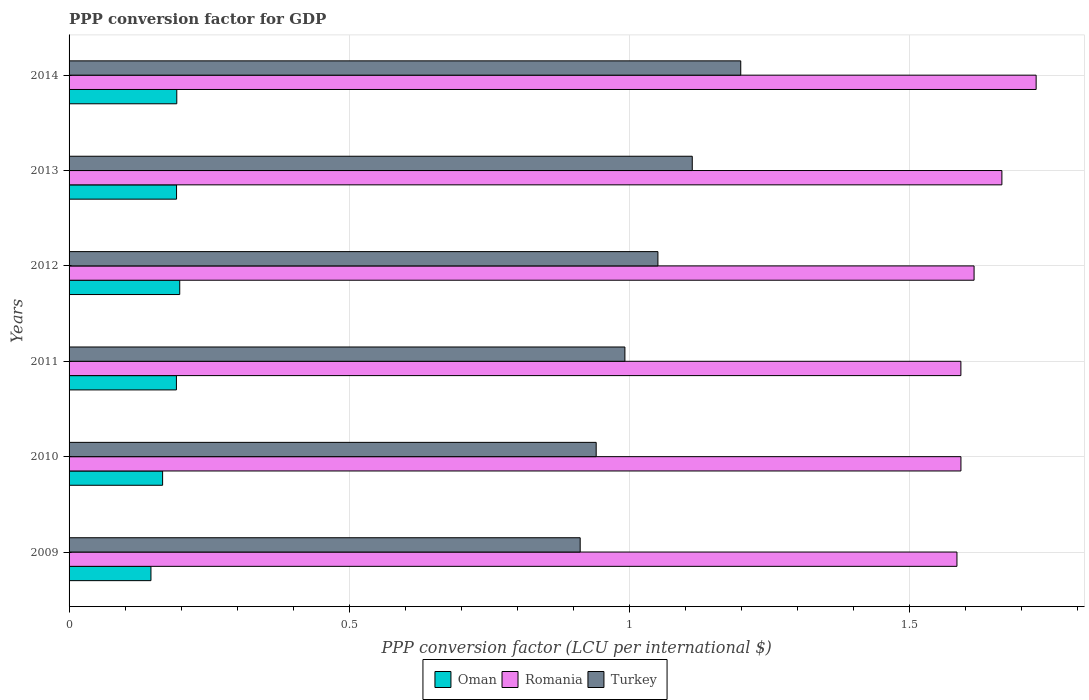How many groups of bars are there?
Offer a terse response. 6. Are the number of bars on each tick of the Y-axis equal?
Provide a short and direct response. Yes. How many bars are there on the 5th tick from the top?
Provide a short and direct response. 3. How many bars are there on the 2nd tick from the bottom?
Provide a short and direct response. 3. In how many cases, is the number of bars for a given year not equal to the number of legend labels?
Make the answer very short. 0. What is the PPP conversion factor for GDP in Oman in 2014?
Provide a succinct answer. 0.19. Across all years, what is the maximum PPP conversion factor for GDP in Oman?
Give a very brief answer. 0.2. Across all years, what is the minimum PPP conversion factor for GDP in Turkey?
Give a very brief answer. 0.91. In which year was the PPP conversion factor for GDP in Turkey maximum?
Give a very brief answer. 2014. What is the total PPP conversion factor for GDP in Romania in the graph?
Your answer should be very brief. 9.77. What is the difference between the PPP conversion factor for GDP in Romania in 2009 and that in 2010?
Your response must be concise. -0.01. What is the difference between the PPP conversion factor for GDP in Oman in 2011 and the PPP conversion factor for GDP in Turkey in 2013?
Your response must be concise. -0.92. What is the average PPP conversion factor for GDP in Romania per year?
Your answer should be compact. 1.63. In the year 2012, what is the difference between the PPP conversion factor for GDP in Oman and PPP conversion factor for GDP in Romania?
Your answer should be compact. -1.42. What is the ratio of the PPP conversion factor for GDP in Romania in 2010 to that in 2012?
Provide a succinct answer. 0.99. Is the difference between the PPP conversion factor for GDP in Oman in 2013 and 2014 greater than the difference between the PPP conversion factor for GDP in Romania in 2013 and 2014?
Your answer should be compact. Yes. What is the difference between the highest and the second highest PPP conversion factor for GDP in Turkey?
Your answer should be compact. 0.09. What is the difference between the highest and the lowest PPP conversion factor for GDP in Turkey?
Provide a succinct answer. 0.29. In how many years, is the PPP conversion factor for GDP in Oman greater than the average PPP conversion factor for GDP in Oman taken over all years?
Offer a very short reply. 4. Is the sum of the PPP conversion factor for GDP in Turkey in 2010 and 2012 greater than the maximum PPP conversion factor for GDP in Romania across all years?
Your answer should be very brief. Yes. What does the 2nd bar from the top in 2012 represents?
Provide a succinct answer. Romania. How many years are there in the graph?
Your answer should be very brief. 6. What is the difference between two consecutive major ticks on the X-axis?
Your answer should be compact. 0.5. Does the graph contain any zero values?
Your response must be concise. No. How many legend labels are there?
Your answer should be very brief. 3. How are the legend labels stacked?
Your answer should be compact. Horizontal. What is the title of the graph?
Keep it short and to the point. PPP conversion factor for GDP. Does "Kosovo" appear as one of the legend labels in the graph?
Keep it short and to the point. No. What is the label or title of the X-axis?
Provide a short and direct response. PPP conversion factor (LCU per international $). What is the PPP conversion factor (LCU per international $) of Oman in 2009?
Provide a short and direct response. 0.15. What is the PPP conversion factor (LCU per international $) of Romania in 2009?
Your answer should be compact. 1.58. What is the PPP conversion factor (LCU per international $) in Turkey in 2009?
Make the answer very short. 0.91. What is the PPP conversion factor (LCU per international $) in Oman in 2010?
Provide a short and direct response. 0.17. What is the PPP conversion factor (LCU per international $) in Romania in 2010?
Provide a succinct answer. 1.59. What is the PPP conversion factor (LCU per international $) of Turkey in 2010?
Keep it short and to the point. 0.94. What is the PPP conversion factor (LCU per international $) in Oman in 2011?
Your answer should be very brief. 0.19. What is the PPP conversion factor (LCU per international $) of Romania in 2011?
Give a very brief answer. 1.59. What is the PPP conversion factor (LCU per international $) in Turkey in 2011?
Provide a short and direct response. 0.99. What is the PPP conversion factor (LCU per international $) of Oman in 2012?
Provide a succinct answer. 0.2. What is the PPP conversion factor (LCU per international $) in Romania in 2012?
Provide a short and direct response. 1.61. What is the PPP conversion factor (LCU per international $) in Turkey in 2012?
Offer a very short reply. 1.05. What is the PPP conversion factor (LCU per international $) in Oman in 2013?
Provide a short and direct response. 0.19. What is the PPP conversion factor (LCU per international $) of Romania in 2013?
Offer a very short reply. 1.66. What is the PPP conversion factor (LCU per international $) in Turkey in 2013?
Your answer should be very brief. 1.11. What is the PPP conversion factor (LCU per international $) in Oman in 2014?
Offer a terse response. 0.19. What is the PPP conversion factor (LCU per international $) of Romania in 2014?
Your answer should be compact. 1.73. What is the PPP conversion factor (LCU per international $) in Turkey in 2014?
Make the answer very short. 1.2. Across all years, what is the maximum PPP conversion factor (LCU per international $) of Oman?
Make the answer very short. 0.2. Across all years, what is the maximum PPP conversion factor (LCU per international $) of Romania?
Your answer should be compact. 1.73. Across all years, what is the maximum PPP conversion factor (LCU per international $) in Turkey?
Provide a succinct answer. 1.2. Across all years, what is the minimum PPP conversion factor (LCU per international $) in Oman?
Ensure brevity in your answer.  0.15. Across all years, what is the minimum PPP conversion factor (LCU per international $) in Romania?
Your response must be concise. 1.58. Across all years, what is the minimum PPP conversion factor (LCU per international $) of Turkey?
Offer a very short reply. 0.91. What is the total PPP conversion factor (LCU per international $) in Oman in the graph?
Ensure brevity in your answer.  1.09. What is the total PPP conversion factor (LCU per international $) in Romania in the graph?
Your answer should be very brief. 9.77. What is the total PPP conversion factor (LCU per international $) of Turkey in the graph?
Keep it short and to the point. 6.21. What is the difference between the PPP conversion factor (LCU per international $) of Oman in 2009 and that in 2010?
Give a very brief answer. -0.02. What is the difference between the PPP conversion factor (LCU per international $) in Romania in 2009 and that in 2010?
Your answer should be very brief. -0.01. What is the difference between the PPP conversion factor (LCU per international $) of Turkey in 2009 and that in 2010?
Give a very brief answer. -0.03. What is the difference between the PPP conversion factor (LCU per international $) in Oman in 2009 and that in 2011?
Your response must be concise. -0.05. What is the difference between the PPP conversion factor (LCU per international $) in Romania in 2009 and that in 2011?
Give a very brief answer. -0.01. What is the difference between the PPP conversion factor (LCU per international $) in Turkey in 2009 and that in 2011?
Give a very brief answer. -0.08. What is the difference between the PPP conversion factor (LCU per international $) of Oman in 2009 and that in 2012?
Offer a terse response. -0.05. What is the difference between the PPP conversion factor (LCU per international $) of Romania in 2009 and that in 2012?
Provide a succinct answer. -0.03. What is the difference between the PPP conversion factor (LCU per international $) in Turkey in 2009 and that in 2012?
Keep it short and to the point. -0.14. What is the difference between the PPP conversion factor (LCU per international $) in Oman in 2009 and that in 2013?
Provide a short and direct response. -0.05. What is the difference between the PPP conversion factor (LCU per international $) in Romania in 2009 and that in 2013?
Offer a terse response. -0.08. What is the difference between the PPP conversion factor (LCU per international $) of Oman in 2009 and that in 2014?
Your response must be concise. -0.05. What is the difference between the PPP conversion factor (LCU per international $) of Romania in 2009 and that in 2014?
Your answer should be very brief. -0.14. What is the difference between the PPP conversion factor (LCU per international $) of Turkey in 2009 and that in 2014?
Offer a terse response. -0.29. What is the difference between the PPP conversion factor (LCU per international $) in Oman in 2010 and that in 2011?
Keep it short and to the point. -0.02. What is the difference between the PPP conversion factor (LCU per international $) of Romania in 2010 and that in 2011?
Your answer should be very brief. 0. What is the difference between the PPP conversion factor (LCU per international $) of Turkey in 2010 and that in 2011?
Provide a succinct answer. -0.05. What is the difference between the PPP conversion factor (LCU per international $) in Oman in 2010 and that in 2012?
Provide a short and direct response. -0.03. What is the difference between the PPP conversion factor (LCU per international $) of Romania in 2010 and that in 2012?
Provide a short and direct response. -0.02. What is the difference between the PPP conversion factor (LCU per international $) in Turkey in 2010 and that in 2012?
Your answer should be compact. -0.11. What is the difference between the PPP conversion factor (LCU per international $) of Oman in 2010 and that in 2013?
Keep it short and to the point. -0.02. What is the difference between the PPP conversion factor (LCU per international $) in Romania in 2010 and that in 2013?
Offer a terse response. -0.07. What is the difference between the PPP conversion factor (LCU per international $) of Turkey in 2010 and that in 2013?
Offer a very short reply. -0.17. What is the difference between the PPP conversion factor (LCU per international $) of Oman in 2010 and that in 2014?
Keep it short and to the point. -0.03. What is the difference between the PPP conversion factor (LCU per international $) of Romania in 2010 and that in 2014?
Your response must be concise. -0.13. What is the difference between the PPP conversion factor (LCU per international $) of Turkey in 2010 and that in 2014?
Give a very brief answer. -0.26. What is the difference between the PPP conversion factor (LCU per international $) of Oman in 2011 and that in 2012?
Ensure brevity in your answer.  -0.01. What is the difference between the PPP conversion factor (LCU per international $) in Romania in 2011 and that in 2012?
Your answer should be very brief. -0.02. What is the difference between the PPP conversion factor (LCU per international $) of Turkey in 2011 and that in 2012?
Provide a short and direct response. -0.06. What is the difference between the PPP conversion factor (LCU per international $) in Oman in 2011 and that in 2013?
Your answer should be very brief. -0. What is the difference between the PPP conversion factor (LCU per international $) in Romania in 2011 and that in 2013?
Your answer should be very brief. -0.07. What is the difference between the PPP conversion factor (LCU per international $) in Turkey in 2011 and that in 2013?
Offer a terse response. -0.12. What is the difference between the PPP conversion factor (LCU per international $) in Oman in 2011 and that in 2014?
Your answer should be compact. -0. What is the difference between the PPP conversion factor (LCU per international $) in Romania in 2011 and that in 2014?
Your answer should be very brief. -0.13. What is the difference between the PPP conversion factor (LCU per international $) in Turkey in 2011 and that in 2014?
Give a very brief answer. -0.21. What is the difference between the PPP conversion factor (LCU per international $) of Oman in 2012 and that in 2013?
Provide a short and direct response. 0.01. What is the difference between the PPP conversion factor (LCU per international $) in Romania in 2012 and that in 2013?
Your response must be concise. -0.05. What is the difference between the PPP conversion factor (LCU per international $) in Turkey in 2012 and that in 2013?
Keep it short and to the point. -0.06. What is the difference between the PPP conversion factor (LCU per international $) of Oman in 2012 and that in 2014?
Your answer should be very brief. 0.01. What is the difference between the PPP conversion factor (LCU per international $) in Romania in 2012 and that in 2014?
Provide a short and direct response. -0.11. What is the difference between the PPP conversion factor (LCU per international $) in Turkey in 2012 and that in 2014?
Offer a very short reply. -0.15. What is the difference between the PPP conversion factor (LCU per international $) of Oman in 2013 and that in 2014?
Give a very brief answer. -0. What is the difference between the PPP conversion factor (LCU per international $) of Romania in 2013 and that in 2014?
Offer a very short reply. -0.06. What is the difference between the PPP conversion factor (LCU per international $) in Turkey in 2013 and that in 2014?
Offer a very short reply. -0.09. What is the difference between the PPP conversion factor (LCU per international $) of Oman in 2009 and the PPP conversion factor (LCU per international $) of Romania in 2010?
Your answer should be very brief. -1.45. What is the difference between the PPP conversion factor (LCU per international $) in Oman in 2009 and the PPP conversion factor (LCU per international $) in Turkey in 2010?
Make the answer very short. -0.79. What is the difference between the PPP conversion factor (LCU per international $) of Romania in 2009 and the PPP conversion factor (LCU per international $) of Turkey in 2010?
Ensure brevity in your answer.  0.64. What is the difference between the PPP conversion factor (LCU per international $) in Oman in 2009 and the PPP conversion factor (LCU per international $) in Romania in 2011?
Make the answer very short. -1.45. What is the difference between the PPP conversion factor (LCU per international $) of Oman in 2009 and the PPP conversion factor (LCU per international $) of Turkey in 2011?
Ensure brevity in your answer.  -0.85. What is the difference between the PPP conversion factor (LCU per international $) of Romania in 2009 and the PPP conversion factor (LCU per international $) of Turkey in 2011?
Provide a succinct answer. 0.59. What is the difference between the PPP conversion factor (LCU per international $) of Oman in 2009 and the PPP conversion factor (LCU per international $) of Romania in 2012?
Make the answer very short. -1.47. What is the difference between the PPP conversion factor (LCU per international $) in Oman in 2009 and the PPP conversion factor (LCU per international $) in Turkey in 2012?
Your answer should be very brief. -0.9. What is the difference between the PPP conversion factor (LCU per international $) of Romania in 2009 and the PPP conversion factor (LCU per international $) of Turkey in 2012?
Your answer should be compact. 0.53. What is the difference between the PPP conversion factor (LCU per international $) of Oman in 2009 and the PPP conversion factor (LCU per international $) of Romania in 2013?
Your answer should be compact. -1.52. What is the difference between the PPP conversion factor (LCU per international $) of Oman in 2009 and the PPP conversion factor (LCU per international $) of Turkey in 2013?
Your response must be concise. -0.97. What is the difference between the PPP conversion factor (LCU per international $) of Romania in 2009 and the PPP conversion factor (LCU per international $) of Turkey in 2013?
Ensure brevity in your answer.  0.47. What is the difference between the PPP conversion factor (LCU per international $) of Oman in 2009 and the PPP conversion factor (LCU per international $) of Romania in 2014?
Offer a very short reply. -1.58. What is the difference between the PPP conversion factor (LCU per international $) of Oman in 2009 and the PPP conversion factor (LCU per international $) of Turkey in 2014?
Offer a very short reply. -1.05. What is the difference between the PPP conversion factor (LCU per international $) in Romania in 2009 and the PPP conversion factor (LCU per international $) in Turkey in 2014?
Offer a terse response. 0.39. What is the difference between the PPP conversion factor (LCU per international $) in Oman in 2010 and the PPP conversion factor (LCU per international $) in Romania in 2011?
Ensure brevity in your answer.  -1.42. What is the difference between the PPP conversion factor (LCU per international $) of Oman in 2010 and the PPP conversion factor (LCU per international $) of Turkey in 2011?
Your answer should be compact. -0.82. What is the difference between the PPP conversion factor (LCU per international $) of Romania in 2010 and the PPP conversion factor (LCU per international $) of Turkey in 2011?
Your response must be concise. 0.6. What is the difference between the PPP conversion factor (LCU per international $) of Oman in 2010 and the PPP conversion factor (LCU per international $) of Romania in 2012?
Provide a short and direct response. -1.45. What is the difference between the PPP conversion factor (LCU per international $) of Oman in 2010 and the PPP conversion factor (LCU per international $) of Turkey in 2012?
Provide a succinct answer. -0.88. What is the difference between the PPP conversion factor (LCU per international $) in Romania in 2010 and the PPP conversion factor (LCU per international $) in Turkey in 2012?
Offer a very short reply. 0.54. What is the difference between the PPP conversion factor (LCU per international $) in Oman in 2010 and the PPP conversion factor (LCU per international $) in Romania in 2013?
Your answer should be very brief. -1.5. What is the difference between the PPP conversion factor (LCU per international $) of Oman in 2010 and the PPP conversion factor (LCU per international $) of Turkey in 2013?
Your response must be concise. -0.95. What is the difference between the PPP conversion factor (LCU per international $) of Romania in 2010 and the PPP conversion factor (LCU per international $) of Turkey in 2013?
Provide a succinct answer. 0.48. What is the difference between the PPP conversion factor (LCU per international $) of Oman in 2010 and the PPP conversion factor (LCU per international $) of Romania in 2014?
Your answer should be very brief. -1.56. What is the difference between the PPP conversion factor (LCU per international $) in Oman in 2010 and the PPP conversion factor (LCU per international $) in Turkey in 2014?
Your answer should be very brief. -1.03. What is the difference between the PPP conversion factor (LCU per international $) of Romania in 2010 and the PPP conversion factor (LCU per international $) of Turkey in 2014?
Your answer should be compact. 0.39. What is the difference between the PPP conversion factor (LCU per international $) of Oman in 2011 and the PPP conversion factor (LCU per international $) of Romania in 2012?
Your answer should be very brief. -1.42. What is the difference between the PPP conversion factor (LCU per international $) in Oman in 2011 and the PPP conversion factor (LCU per international $) in Turkey in 2012?
Offer a very short reply. -0.86. What is the difference between the PPP conversion factor (LCU per international $) in Romania in 2011 and the PPP conversion factor (LCU per international $) in Turkey in 2012?
Make the answer very short. 0.54. What is the difference between the PPP conversion factor (LCU per international $) in Oman in 2011 and the PPP conversion factor (LCU per international $) in Romania in 2013?
Ensure brevity in your answer.  -1.47. What is the difference between the PPP conversion factor (LCU per international $) in Oman in 2011 and the PPP conversion factor (LCU per international $) in Turkey in 2013?
Make the answer very short. -0.92. What is the difference between the PPP conversion factor (LCU per international $) of Romania in 2011 and the PPP conversion factor (LCU per international $) of Turkey in 2013?
Your answer should be very brief. 0.48. What is the difference between the PPP conversion factor (LCU per international $) in Oman in 2011 and the PPP conversion factor (LCU per international $) in Romania in 2014?
Make the answer very short. -1.53. What is the difference between the PPP conversion factor (LCU per international $) in Oman in 2011 and the PPP conversion factor (LCU per international $) in Turkey in 2014?
Your answer should be compact. -1.01. What is the difference between the PPP conversion factor (LCU per international $) in Romania in 2011 and the PPP conversion factor (LCU per international $) in Turkey in 2014?
Provide a short and direct response. 0.39. What is the difference between the PPP conversion factor (LCU per international $) in Oman in 2012 and the PPP conversion factor (LCU per international $) in Romania in 2013?
Offer a very short reply. -1.47. What is the difference between the PPP conversion factor (LCU per international $) in Oman in 2012 and the PPP conversion factor (LCU per international $) in Turkey in 2013?
Keep it short and to the point. -0.91. What is the difference between the PPP conversion factor (LCU per international $) of Romania in 2012 and the PPP conversion factor (LCU per international $) of Turkey in 2013?
Provide a short and direct response. 0.5. What is the difference between the PPP conversion factor (LCU per international $) of Oman in 2012 and the PPP conversion factor (LCU per international $) of Romania in 2014?
Give a very brief answer. -1.53. What is the difference between the PPP conversion factor (LCU per international $) in Oman in 2012 and the PPP conversion factor (LCU per international $) in Turkey in 2014?
Ensure brevity in your answer.  -1. What is the difference between the PPP conversion factor (LCU per international $) of Romania in 2012 and the PPP conversion factor (LCU per international $) of Turkey in 2014?
Offer a terse response. 0.42. What is the difference between the PPP conversion factor (LCU per international $) of Oman in 2013 and the PPP conversion factor (LCU per international $) of Romania in 2014?
Offer a very short reply. -1.53. What is the difference between the PPP conversion factor (LCU per international $) in Oman in 2013 and the PPP conversion factor (LCU per international $) in Turkey in 2014?
Your response must be concise. -1.01. What is the difference between the PPP conversion factor (LCU per international $) of Romania in 2013 and the PPP conversion factor (LCU per international $) of Turkey in 2014?
Make the answer very short. 0.47. What is the average PPP conversion factor (LCU per international $) in Oman per year?
Your response must be concise. 0.18. What is the average PPP conversion factor (LCU per international $) of Romania per year?
Give a very brief answer. 1.63. What is the average PPP conversion factor (LCU per international $) in Turkey per year?
Provide a short and direct response. 1.03. In the year 2009, what is the difference between the PPP conversion factor (LCU per international $) in Oman and PPP conversion factor (LCU per international $) in Romania?
Your response must be concise. -1.44. In the year 2009, what is the difference between the PPP conversion factor (LCU per international $) of Oman and PPP conversion factor (LCU per international $) of Turkey?
Provide a succinct answer. -0.77. In the year 2009, what is the difference between the PPP conversion factor (LCU per international $) in Romania and PPP conversion factor (LCU per international $) in Turkey?
Your answer should be compact. 0.67. In the year 2010, what is the difference between the PPP conversion factor (LCU per international $) of Oman and PPP conversion factor (LCU per international $) of Romania?
Give a very brief answer. -1.42. In the year 2010, what is the difference between the PPP conversion factor (LCU per international $) in Oman and PPP conversion factor (LCU per international $) in Turkey?
Offer a terse response. -0.77. In the year 2010, what is the difference between the PPP conversion factor (LCU per international $) of Romania and PPP conversion factor (LCU per international $) of Turkey?
Your answer should be very brief. 0.65. In the year 2011, what is the difference between the PPP conversion factor (LCU per international $) of Oman and PPP conversion factor (LCU per international $) of Romania?
Give a very brief answer. -1.4. In the year 2011, what is the difference between the PPP conversion factor (LCU per international $) of Oman and PPP conversion factor (LCU per international $) of Turkey?
Ensure brevity in your answer.  -0.8. In the year 2011, what is the difference between the PPP conversion factor (LCU per international $) in Romania and PPP conversion factor (LCU per international $) in Turkey?
Ensure brevity in your answer.  0.6. In the year 2012, what is the difference between the PPP conversion factor (LCU per international $) in Oman and PPP conversion factor (LCU per international $) in Romania?
Offer a very short reply. -1.42. In the year 2012, what is the difference between the PPP conversion factor (LCU per international $) of Oman and PPP conversion factor (LCU per international $) of Turkey?
Offer a very short reply. -0.85. In the year 2012, what is the difference between the PPP conversion factor (LCU per international $) in Romania and PPP conversion factor (LCU per international $) in Turkey?
Your answer should be compact. 0.56. In the year 2013, what is the difference between the PPP conversion factor (LCU per international $) of Oman and PPP conversion factor (LCU per international $) of Romania?
Offer a very short reply. -1.47. In the year 2013, what is the difference between the PPP conversion factor (LCU per international $) of Oman and PPP conversion factor (LCU per international $) of Turkey?
Your response must be concise. -0.92. In the year 2013, what is the difference between the PPP conversion factor (LCU per international $) in Romania and PPP conversion factor (LCU per international $) in Turkey?
Ensure brevity in your answer.  0.55. In the year 2014, what is the difference between the PPP conversion factor (LCU per international $) of Oman and PPP conversion factor (LCU per international $) of Romania?
Give a very brief answer. -1.53. In the year 2014, what is the difference between the PPP conversion factor (LCU per international $) of Oman and PPP conversion factor (LCU per international $) of Turkey?
Offer a terse response. -1.01. In the year 2014, what is the difference between the PPP conversion factor (LCU per international $) in Romania and PPP conversion factor (LCU per international $) in Turkey?
Your answer should be compact. 0.53. What is the ratio of the PPP conversion factor (LCU per international $) in Oman in 2009 to that in 2010?
Your response must be concise. 0.88. What is the ratio of the PPP conversion factor (LCU per international $) of Romania in 2009 to that in 2010?
Provide a succinct answer. 1. What is the ratio of the PPP conversion factor (LCU per international $) in Turkey in 2009 to that in 2010?
Your answer should be very brief. 0.97. What is the ratio of the PPP conversion factor (LCU per international $) of Oman in 2009 to that in 2011?
Your answer should be compact. 0.76. What is the ratio of the PPP conversion factor (LCU per international $) in Romania in 2009 to that in 2011?
Your response must be concise. 1. What is the ratio of the PPP conversion factor (LCU per international $) of Turkey in 2009 to that in 2011?
Your answer should be very brief. 0.92. What is the ratio of the PPP conversion factor (LCU per international $) of Oman in 2009 to that in 2012?
Your response must be concise. 0.74. What is the ratio of the PPP conversion factor (LCU per international $) in Romania in 2009 to that in 2012?
Make the answer very short. 0.98. What is the ratio of the PPP conversion factor (LCU per international $) of Turkey in 2009 to that in 2012?
Give a very brief answer. 0.87. What is the ratio of the PPP conversion factor (LCU per international $) of Oman in 2009 to that in 2013?
Ensure brevity in your answer.  0.76. What is the ratio of the PPP conversion factor (LCU per international $) in Romania in 2009 to that in 2013?
Keep it short and to the point. 0.95. What is the ratio of the PPP conversion factor (LCU per international $) in Turkey in 2009 to that in 2013?
Keep it short and to the point. 0.82. What is the ratio of the PPP conversion factor (LCU per international $) of Oman in 2009 to that in 2014?
Offer a very short reply. 0.76. What is the ratio of the PPP conversion factor (LCU per international $) in Romania in 2009 to that in 2014?
Give a very brief answer. 0.92. What is the ratio of the PPP conversion factor (LCU per international $) of Turkey in 2009 to that in 2014?
Provide a succinct answer. 0.76. What is the ratio of the PPP conversion factor (LCU per international $) in Oman in 2010 to that in 2011?
Your answer should be very brief. 0.87. What is the ratio of the PPP conversion factor (LCU per international $) of Romania in 2010 to that in 2011?
Provide a succinct answer. 1. What is the ratio of the PPP conversion factor (LCU per international $) of Turkey in 2010 to that in 2011?
Provide a succinct answer. 0.95. What is the ratio of the PPP conversion factor (LCU per international $) in Oman in 2010 to that in 2012?
Your answer should be very brief. 0.85. What is the ratio of the PPP conversion factor (LCU per international $) of Romania in 2010 to that in 2012?
Keep it short and to the point. 0.99. What is the ratio of the PPP conversion factor (LCU per international $) of Turkey in 2010 to that in 2012?
Your answer should be very brief. 0.9. What is the ratio of the PPP conversion factor (LCU per international $) in Oman in 2010 to that in 2013?
Ensure brevity in your answer.  0.87. What is the ratio of the PPP conversion factor (LCU per international $) of Romania in 2010 to that in 2013?
Provide a succinct answer. 0.96. What is the ratio of the PPP conversion factor (LCU per international $) of Turkey in 2010 to that in 2013?
Make the answer very short. 0.85. What is the ratio of the PPP conversion factor (LCU per international $) in Oman in 2010 to that in 2014?
Keep it short and to the point. 0.87. What is the ratio of the PPP conversion factor (LCU per international $) in Romania in 2010 to that in 2014?
Provide a short and direct response. 0.92. What is the ratio of the PPP conversion factor (LCU per international $) of Turkey in 2010 to that in 2014?
Your response must be concise. 0.78. What is the ratio of the PPP conversion factor (LCU per international $) in Romania in 2011 to that in 2012?
Your answer should be very brief. 0.99. What is the ratio of the PPP conversion factor (LCU per international $) of Turkey in 2011 to that in 2012?
Keep it short and to the point. 0.94. What is the ratio of the PPP conversion factor (LCU per international $) of Romania in 2011 to that in 2013?
Ensure brevity in your answer.  0.96. What is the ratio of the PPP conversion factor (LCU per international $) of Turkey in 2011 to that in 2013?
Offer a very short reply. 0.89. What is the ratio of the PPP conversion factor (LCU per international $) in Romania in 2011 to that in 2014?
Your response must be concise. 0.92. What is the ratio of the PPP conversion factor (LCU per international $) of Turkey in 2011 to that in 2014?
Give a very brief answer. 0.83. What is the ratio of the PPP conversion factor (LCU per international $) in Oman in 2012 to that in 2013?
Keep it short and to the point. 1.03. What is the ratio of the PPP conversion factor (LCU per international $) of Romania in 2012 to that in 2013?
Give a very brief answer. 0.97. What is the ratio of the PPP conversion factor (LCU per international $) in Turkey in 2012 to that in 2013?
Offer a terse response. 0.94. What is the ratio of the PPP conversion factor (LCU per international $) in Oman in 2012 to that in 2014?
Offer a terse response. 1.03. What is the ratio of the PPP conversion factor (LCU per international $) of Romania in 2012 to that in 2014?
Ensure brevity in your answer.  0.94. What is the ratio of the PPP conversion factor (LCU per international $) in Turkey in 2012 to that in 2014?
Offer a very short reply. 0.88. What is the ratio of the PPP conversion factor (LCU per international $) of Oman in 2013 to that in 2014?
Your answer should be very brief. 1. What is the ratio of the PPP conversion factor (LCU per international $) in Romania in 2013 to that in 2014?
Your answer should be very brief. 0.96. What is the ratio of the PPP conversion factor (LCU per international $) in Turkey in 2013 to that in 2014?
Offer a very short reply. 0.93. What is the difference between the highest and the second highest PPP conversion factor (LCU per international $) of Oman?
Make the answer very short. 0.01. What is the difference between the highest and the second highest PPP conversion factor (LCU per international $) of Romania?
Give a very brief answer. 0.06. What is the difference between the highest and the second highest PPP conversion factor (LCU per international $) in Turkey?
Give a very brief answer. 0.09. What is the difference between the highest and the lowest PPP conversion factor (LCU per international $) in Oman?
Ensure brevity in your answer.  0.05. What is the difference between the highest and the lowest PPP conversion factor (LCU per international $) of Romania?
Give a very brief answer. 0.14. What is the difference between the highest and the lowest PPP conversion factor (LCU per international $) in Turkey?
Offer a terse response. 0.29. 